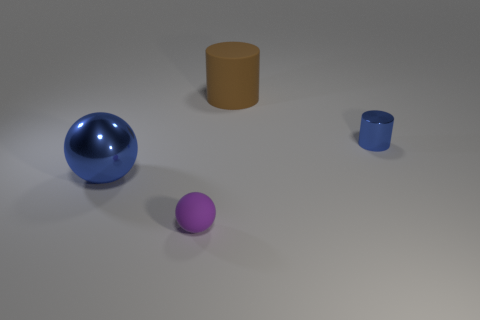Subtract all yellow balls. Subtract all purple cubes. How many balls are left? 2 Add 3 tiny shiny objects. How many objects exist? 7 Add 1 blue matte objects. How many blue matte objects exist? 1 Subtract 0 gray cylinders. How many objects are left? 4 Subtract all brown matte cubes. Subtract all spheres. How many objects are left? 2 Add 3 blue cylinders. How many blue cylinders are left? 4 